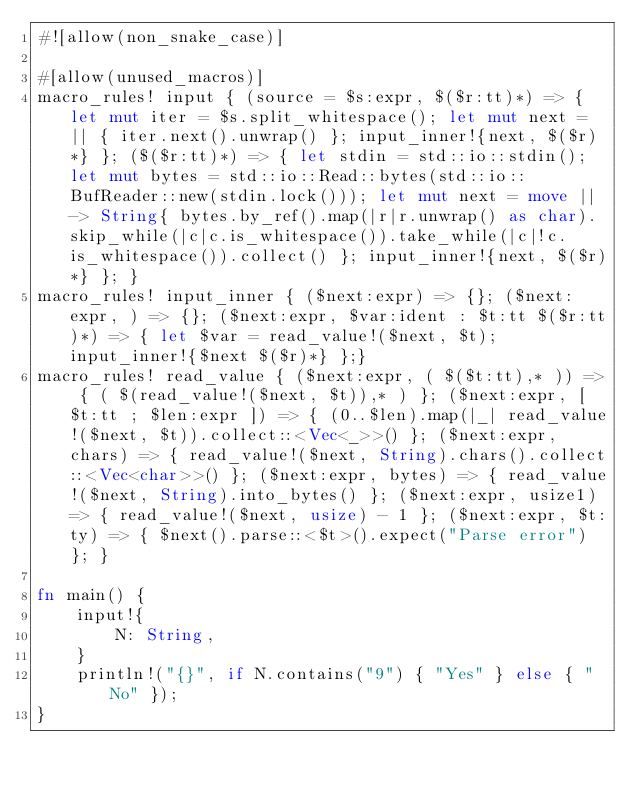Convert code to text. <code><loc_0><loc_0><loc_500><loc_500><_Rust_>#![allow(non_snake_case)]

#[allow(unused_macros)]
macro_rules! input { (source = $s:expr, $($r:tt)*) => { let mut iter = $s.split_whitespace(); let mut next = || { iter.next().unwrap() }; input_inner!{next, $($r)*} }; ($($r:tt)*) => { let stdin = std::io::stdin(); let mut bytes = std::io::Read::bytes(std::io::BufReader::new(stdin.lock())); let mut next = move || -> String{ bytes.by_ref().map(|r|r.unwrap() as char).skip_while(|c|c.is_whitespace()).take_while(|c|!c.is_whitespace()).collect() }; input_inner!{next, $($r)*} }; }
macro_rules! input_inner { ($next:expr) => {}; ($next:expr, ) => {}; ($next:expr, $var:ident : $t:tt $($r:tt)*) => { let $var = read_value!($next, $t); input_inner!{$next $($r)*} };}
macro_rules! read_value { ($next:expr, ( $($t:tt),* )) => { ( $(read_value!($next, $t)),* ) }; ($next:expr, [ $t:tt ; $len:expr ]) => { (0..$len).map(|_| read_value!($next, $t)).collect::<Vec<_>>() }; ($next:expr, chars) => { read_value!($next, String).chars().collect::<Vec<char>>() }; ($next:expr, bytes) => { read_value!($next, String).into_bytes() }; ($next:expr, usize1) => { read_value!($next, usize) - 1 }; ($next:expr, $t:ty) => { $next().parse::<$t>().expect("Parse error") }; }

fn main() {
    input!{
        N: String,
    }
    println!("{}", if N.contains("9") { "Yes" } else { "No" });
}
</code> 